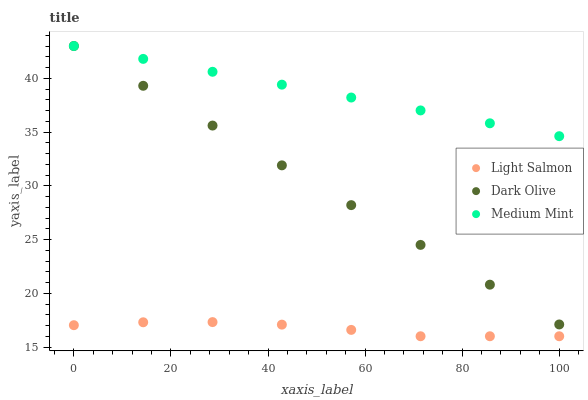Does Light Salmon have the minimum area under the curve?
Answer yes or no. Yes. Does Medium Mint have the maximum area under the curve?
Answer yes or no. Yes. Does Dark Olive have the minimum area under the curve?
Answer yes or no. No. Does Dark Olive have the maximum area under the curve?
Answer yes or no. No. Is Dark Olive the smoothest?
Answer yes or no. Yes. Is Light Salmon the roughest?
Answer yes or no. Yes. Is Light Salmon the smoothest?
Answer yes or no. No. Is Dark Olive the roughest?
Answer yes or no. No. Does Light Salmon have the lowest value?
Answer yes or no. Yes. Does Dark Olive have the lowest value?
Answer yes or no. No. Does Dark Olive have the highest value?
Answer yes or no. Yes. Does Light Salmon have the highest value?
Answer yes or no. No. Is Light Salmon less than Dark Olive?
Answer yes or no. Yes. Is Dark Olive greater than Light Salmon?
Answer yes or no. Yes. Does Medium Mint intersect Dark Olive?
Answer yes or no. Yes. Is Medium Mint less than Dark Olive?
Answer yes or no. No. Is Medium Mint greater than Dark Olive?
Answer yes or no. No. Does Light Salmon intersect Dark Olive?
Answer yes or no. No. 